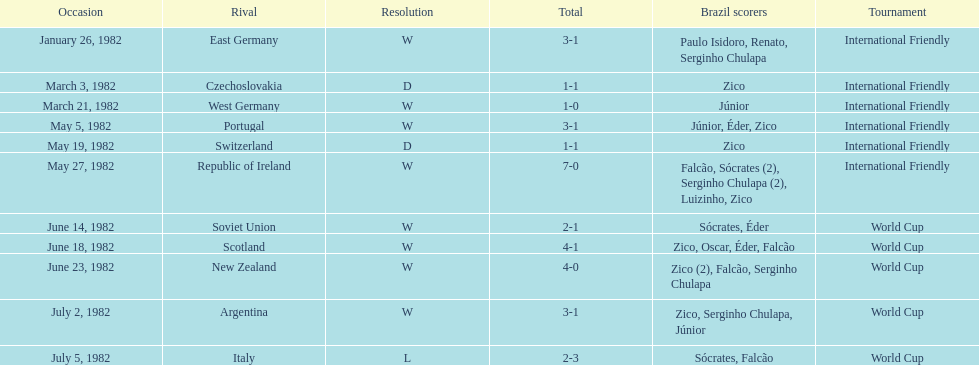How many games did this team play in 1982? 11. 